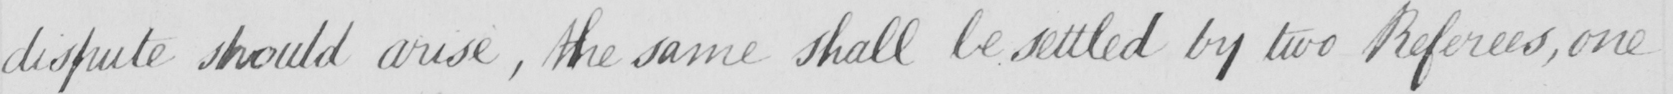What does this handwritten line say? dispute should arise  , the same shall be settled by two Referees , one 